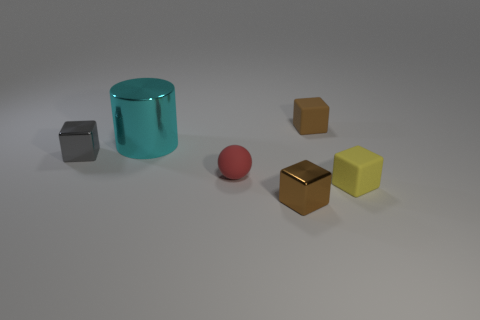Add 1 small gray metal blocks. How many objects exist? 7 Subtract all blocks. How many objects are left? 2 Subtract all small yellow rubber blocks. Subtract all small metallic cubes. How many objects are left? 3 Add 3 brown things. How many brown things are left? 5 Add 5 small red balls. How many small red balls exist? 6 Subtract 0 red cubes. How many objects are left? 6 